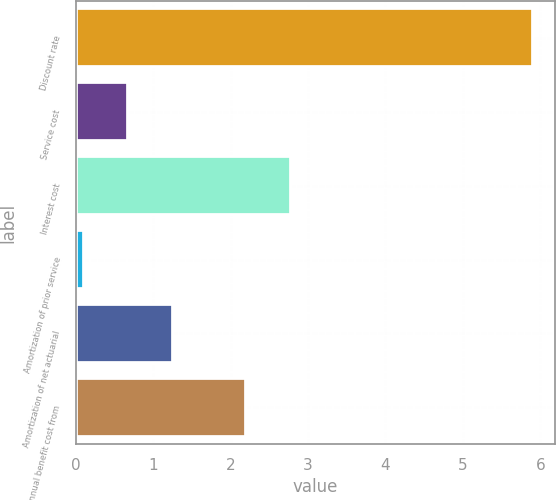Convert chart. <chart><loc_0><loc_0><loc_500><loc_500><bar_chart><fcel>Discount rate<fcel>Service cost<fcel>Interest cost<fcel>Amortization of prior service<fcel>Amortization of net actuarial<fcel>Net annual benefit cost from<nl><fcel>5.9<fcel>0.68<fcel>2.78<fcel>0.1<fcel>1.26<fcel>2.2<nl></chart> 